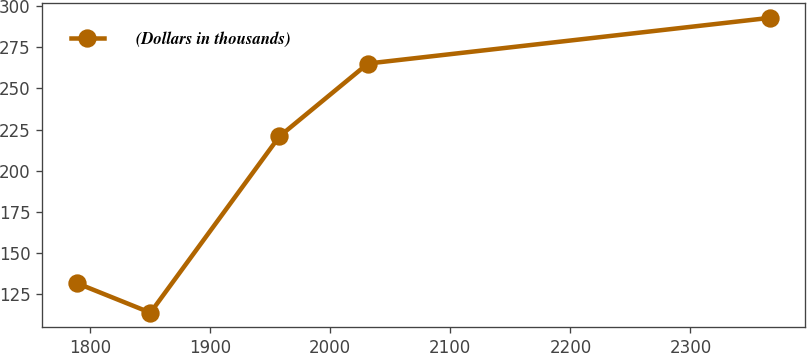Convert chart to OTSL. <chart><loc_0><loc_0><loc_500><loc_500><line_chart><ecel><fcel>(Dollars in thousands)<nl><fcel>1789.01<fcel>131.6<nl><fcel>1850.15<fcel>113.68<nl><fcel>1957.55<fcel>220.78<nl><fcel>2031.33<fcel>265.11<nl><fcel>2366.22<fcel>292.89<nl></chart> 